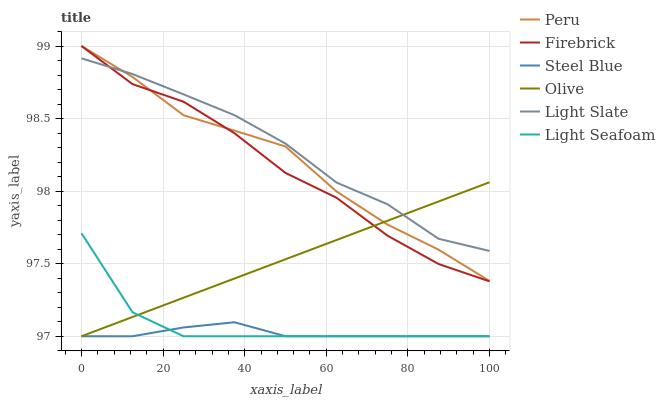Does Steel Blue have the minimum area under the curve?
Answer yes or no. Yes. Does Light Slate have the maximum area under the curve?
Answer yes or no. Yes. Does Firebrick have the minimum area under the curve?
Answer yes or no. No. Does Firebrick have the maximum area under the curve?
Answer yes or no. No. Is Olive the smoothest?
Answer yes or no. Yes. Is Firebrick the roughest?
Answer yes or no. Yes. Is Steel Blue the smoothest?
Answer yes or no. No. Is Steel Blue the roughest?
Answer yes or no. No. Does Firebrick have the lowest value?
Answer yes or no. No. Does Peru have the highest value?
Answer yes or no. Yes. Does Steel Blue have the highest value?
Answer yes or no. No. Is Light Seafoam less than Peru?
Answer yes or no. Yes. Is Light Slate greater than Light Seafoam?
Answer yes or no. Yes. Does Olive intersect Firebrick?
Answer yes or no. Yes. Is Olive less than Firebrick?
Answer yes or no. No. Is Olive greater than Firebrick?
Answer yes or no. No. Does Light Seafoam intersect Peru?
Answer yes or no. No. 